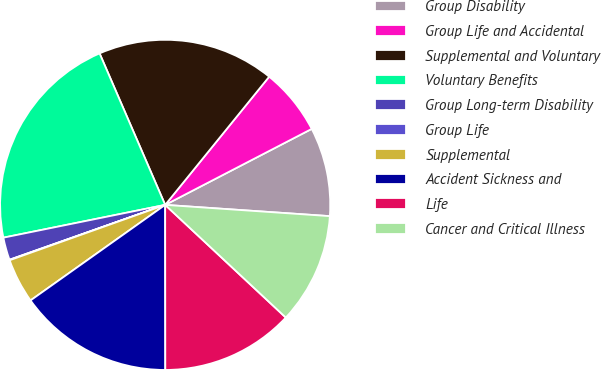Convert chart. <chart><loc_0><loc_0><loc_500><loc_500><pie_chart><fcel>Group Disability<fcel>Group Life and Accidental<fcel>Supplemental and Voluntary<fcel>Voluntary Benefits<fcel>Group Long-term Disability<fcel>Group Life<fcel>Supplemental<fcel>Accident Sickness and<fcel>Life<fcel>Cancer and Critical Illness<nl><fcel>8.7%<fcel>6.54%<fcel>17.35%<fcel>21.68%<fcel>2.21%<fcel>0.05%<fcel>4.38%<fcel>15.19%<fcel>13.03%<fcel>10.87%<nl></chart> 